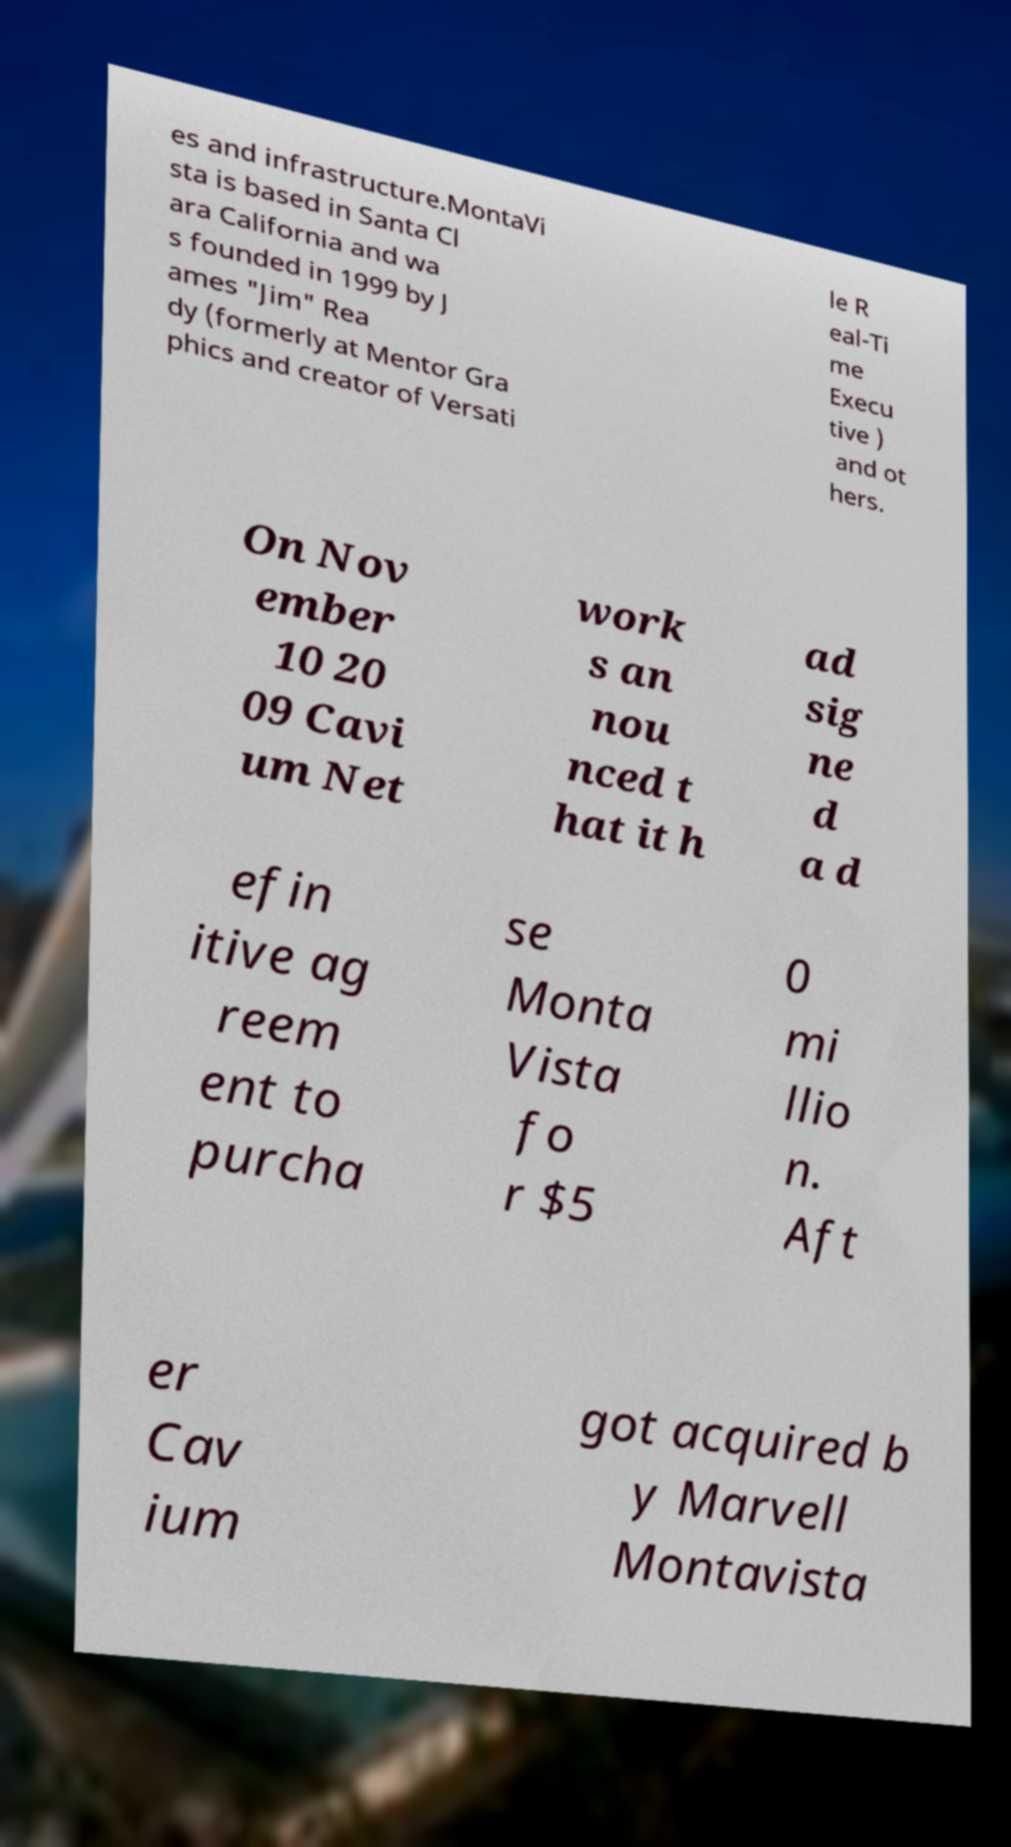For documentation purposes, I need the text within this image transcribed. Could you provide that? es and infrastructure.MontaVi sta is based in Santa Cl ara California and wa s founded in 1999 by J ames "Jim" Rea dy (formerly at Mentor Gra phics and creator of Versati le R eal-Ti me Execu tive ) and ot hers. On Nov ember 10 20 09 Cavi um Net work s an nou nced t hat it h ad sig ne d a d efin itive ag reem ent to purcha se Monta Vista fo r $5 0 mi llio n. Aft er Cav ium got acquired b y Marvell Montavista 